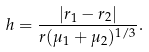<formula> <loc_0><loc_0><loc_500><loc_500>h = \frac { | r _ { 1 } - r _ { 2 } | } { r ( \mu _ { 1 } + \mu _ { 2 } ) ^ { 1 / 3 } } .</formula> 